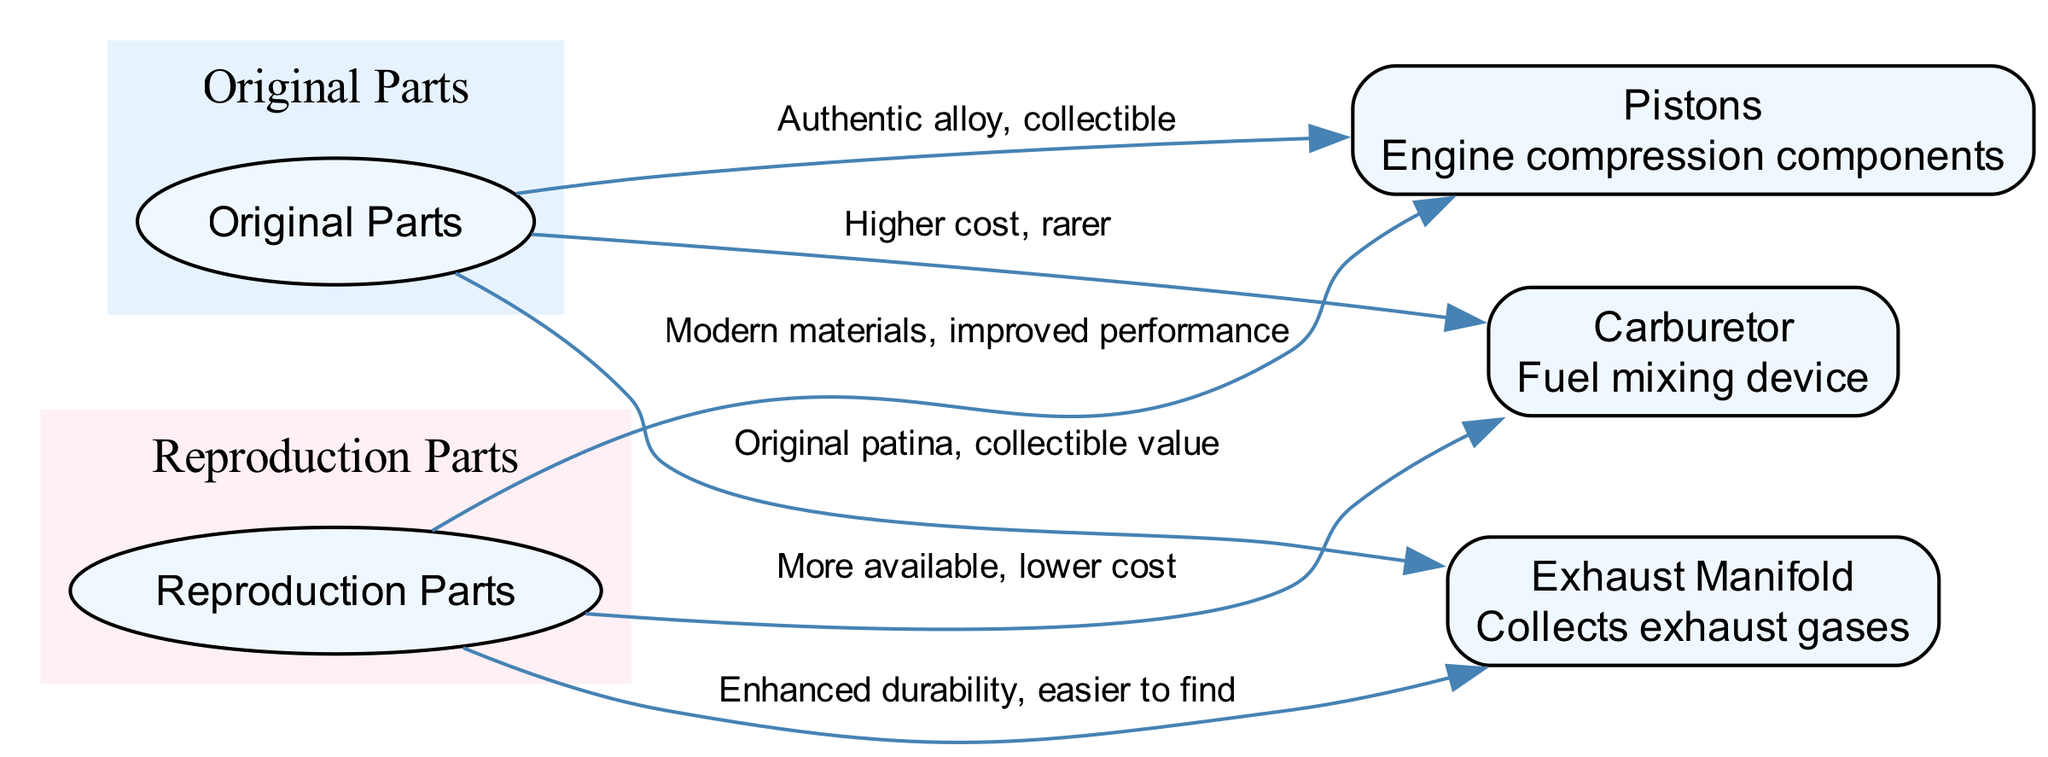What is the relationship between Original Parts and Carburetor? The diagram shows an edge connecting "Original Parts" to "Carburetor" with the label "Higher cost, rarer," indicating that original carburetor parts are more expensive and less common.
Answer: Higher cost, rarer How many total nodes are in the diagram? By counting the nodes listed, there are a total of five nodes representing categories and specific parts related to the engine.
Answer: 5 What benefits do Reproduction Parts offer for Pistons? The diagram connects "Reproduction Parts" to "Pistons" with the label "Modern materials, improved performance," illustrating that reproduction pistons use modern materials that enhance their performance.
Answer: Modern materials, improved performance What is a key feature of Original Parts for Exhaust Manifold? The connection from "Original Parts" to "Exhaust Manifold" is labeled "Original patina, collectible value," conveying that original exhaust manifold parts are valued for their authenticity and historical significance.
Answer: Original patina, collectible value Which part has both Original and Reproduction connections? The diagram displays connections to both "Pistons" and "Carburetor" from both "Original Parts" and "Reproduction Parts," indicating that both have their original and reproduction versions available for restoration.
Answer: Pistons, Carburetor What does the edge between Original Parts and Pistons indicate? The edge connecting "Original Parts" to "Pistons" carries the label "Authentic alloy, collectible," which suggests that original pistons are composed of true Mercedes alloys and hold significant collectible value.
Answer: Authentic alloy, collectible How do Reproduction Parts differ in availability for Exhaust Manifold compared to Original Parts? The label connecting "Reproduction Parts" to "Exhaust Manifold" reads "Enhanced durability, easier to find," implying that reproduction exhaust manifolds are more readily available and offer improved durability compared to original parts.
Answer: Enhanced durability, easier to find What type of diagram is this? This is a High School Level Diagram designed to compare the characteristics and advantages of original versus reproduction parts for a classic Mercedes-Benz engine.
Answer: High School Level Diagram 